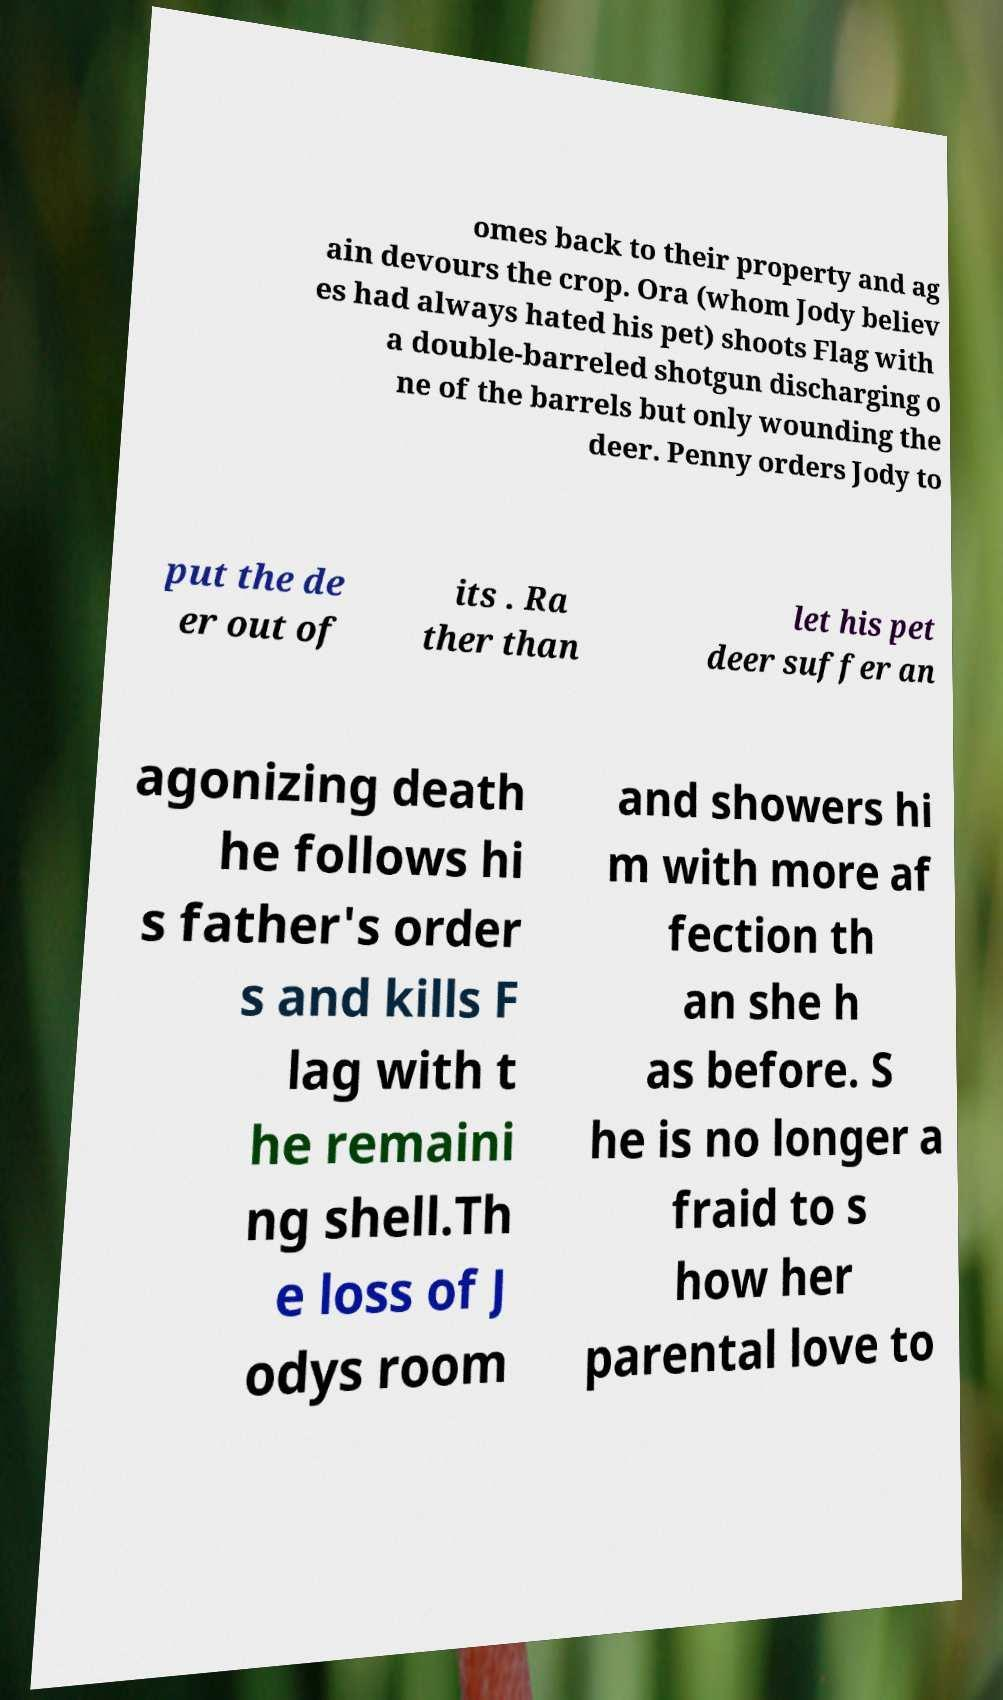I need the written content from this picture converted into text. Can you do that? omes back to their property and ag ain devours the crop. Ora (whom Jody believ es had always hated his pet) shoots Flag with a double-barreled shotgun discharging o ne of the barrels but only wounding the deer. Penny orders Jody to put the de er out of its . Ra ther than let his pet deer suffer an agonizing death he follows hi s father's order s and kills F lag with t he remaini ng shell.Th e loss of J odys room and showers hi m with more af fection th an she h as before. S he is no longer a fraid to s how her parental love to 